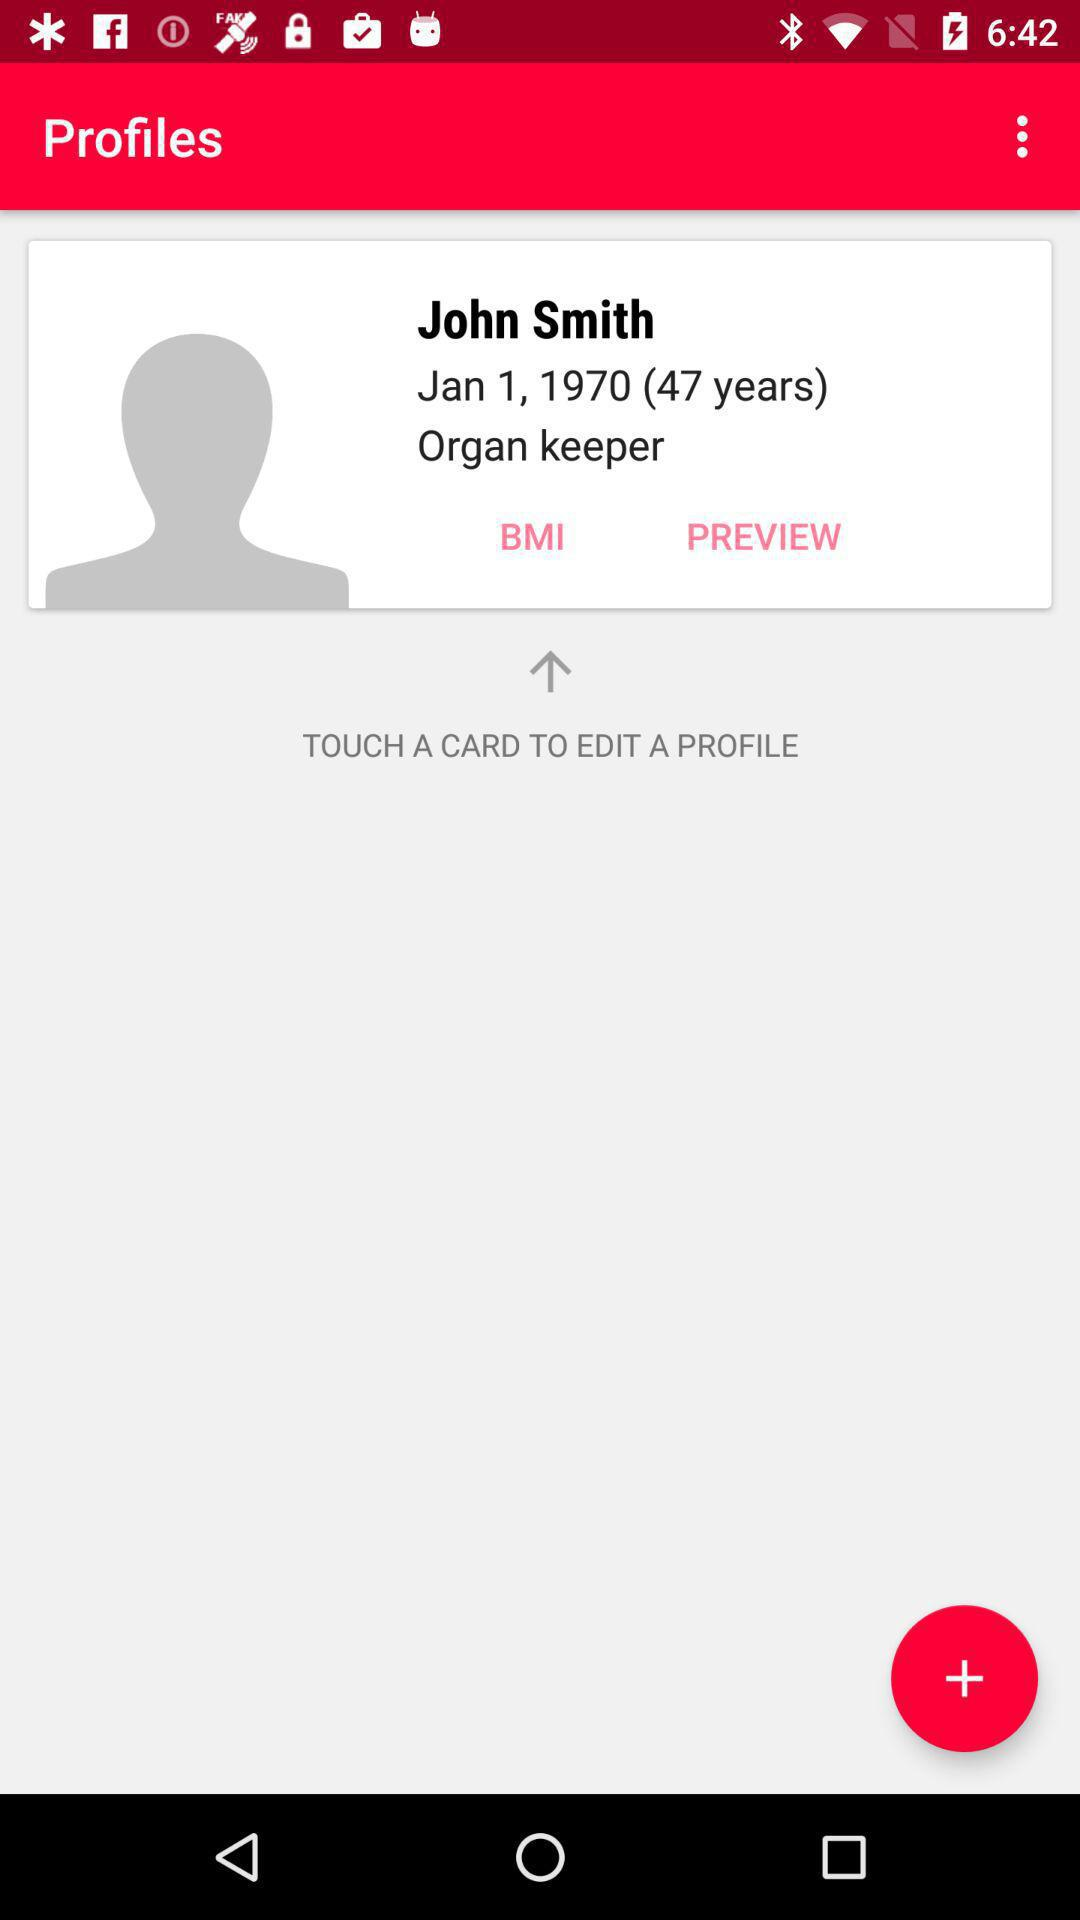How many more years old is John Smith than the date shown?
Answer the question using a single word or phrase. 47 